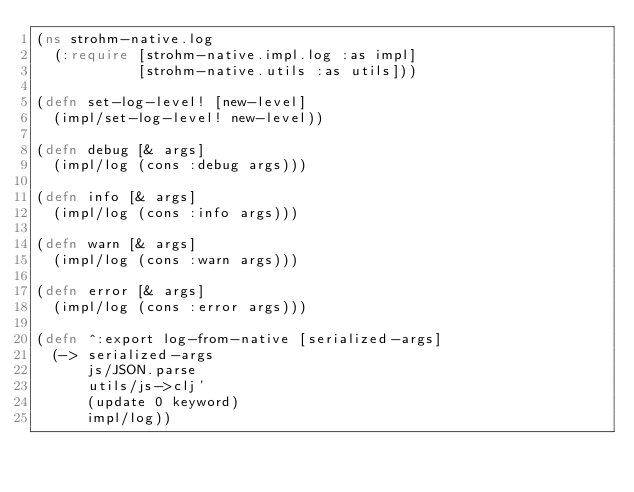Convert code to text. <code><loc_0><loc_0><loc_500><loc_500><_Clojure_>(ns strohm-native.log
  (:require [strohm-native.impl.log :as impl]
            [strohm-native.utils :as utils]))

(defn set-log-level! [new-level]
  (impl/set-log-level! new-level))

(defn debug [& args]
  (impl/log (cons :debug args)))

(defn info [& args]
  (impl/log (cons :info args)))

(defn warn [& args]
  (impl/log (cons :warn args)))

(defn error [& args]
  (impl/log (cons :error args)))

(defn ^:export log-from-native [serialized-args]
  (-> serialized-args
      js/JSON.parse
      utils/js->clj'
      (update 0 keyword)
      impl/log))
</code> 